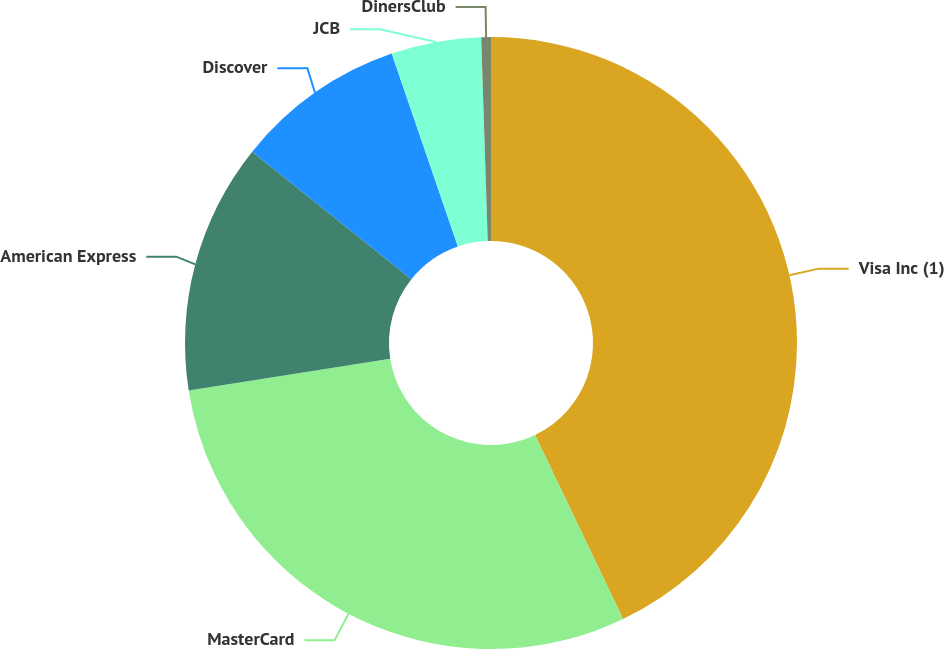<chart> <loc_0><loc_0><loc_500><loc_500><pie_chart><fcel>Visa Inc (1)<fcel>MasterCard<fcel>American Express<fcel>Discover<fcel>JCB<fcel>DinersClub<nl><fcel>42.9%<fcel>29.63%<fcel>13.23%<fcel>8.99%<fcel>4.75%<fcel>0.51%<nl></chart> 